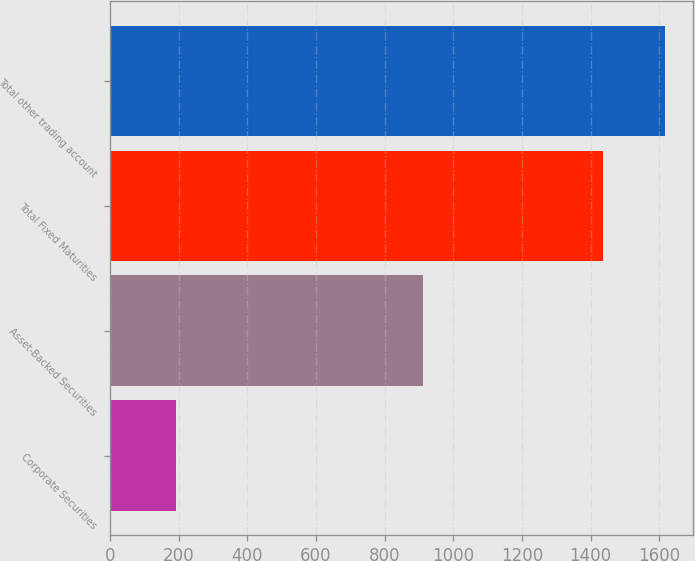Convert chart. <chart><loc_0><loc_0><loc_500><loc_500><bar_chart><fcel>Corporate Securities<fcel>Asset-Backed Securities<fcel>Total Fixed Maturities<fcel>Total other trading account<nl><fcel>192<fcel>913<fcel>1435<fcel>1616<nl></chart> 